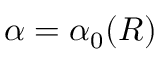<formula> <loc_0><loc_0><loc_500><loc_500>\alpha = \alpha _ { 0 } ( R )</formula> 